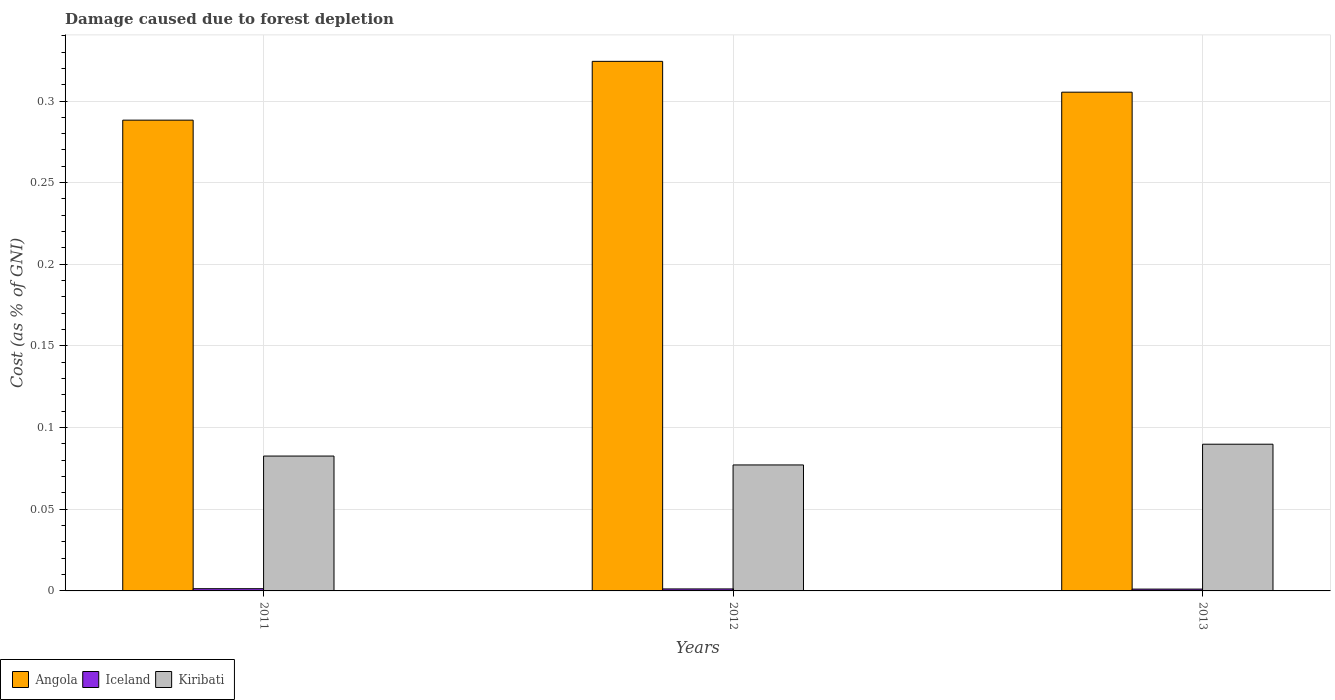How many different coloured bars are there?
Ensure brevity in your answer.  3. Are the number of bars on each tick of the X-axis equal?
Your answer should be very brief. Yes. How many bars are there on the 2nd tick from the right?
Make the answer very short. 3. What is the label of the 1st group of bars from the left?
Keep it short and to the point. 2011. What is the cost of damage caused due to forest depletion in Kiribati in 2013?
Provide a succinct answer. 0.09. Across all years, what is the maximum cost of damage caused due to forest depletion in Kiribati?
Offer a terse response. 0.09. Across all years, what is the minimum cost of damage caused due to forest depletion in Kiribati?
Your response must be concise. 0.08. In which year was the cost of damage caused due to forest depletion in Iceland minimum?
Offer a very short reply. 2013. What is the total cost of damage caused due to forest depletion in Iceland in the graph?
Your response must be concise. 0. What is the difference between the cost of damage caused due to forest depletion in Kiribati in 2012 and that in 2013?
Provide a short and direct response. -0.01. What is the difference between the cost of damage caused due to forest depletion in Iceland in 2012 and the cost of damage caused due to forest depletion in Kiribati in 2013?
Your answer should be very brief. -0.09. What is the average cost of damage caused due to forest depletion in Iceland per year?
Offer a terse response. 0. In the year 2013, what is the difference between the cost of damage caused due to forest depletion in Iceland and cost of damage caused due to forest depletion in Angola?
Your answer should be very brief. -0.3. What is the ratio of the cost of damage caused due to forest depletion in Angola in 2012 to that in 2013?
Keep it short and to the point. 1.06. Is the cost of damage caused due to forest depletion in Iceland in 2011 less than that in 2013?
Provide a succinct answer. No. Is the difference between the cost of damage caused due to forest depletion in Iceland in 2011 and 2012 greater than the difference between the cost of damage caused due to forest depletion in Angola in 2011 and 2012?
Make the answer very short. Yes. What is the difference between the highest and the second highest cost of damage caused due to forest depletion in Angola?
Ensure brevity in your answer.  0.02. What is the difference between the highest and the lowest cost of damage caused due to forest depletion in Angola?
Make the answer very short. 0.04. What does the 1st bar from the left in 2013 represents?
Ensure brevity in your answer.  Angola. What does the 3rd bar from the right in 2011 represents?
Keep it short and to the point. Angola. Are all the bars in the graph horizontal?
Provide a short and direct response. No. How many years are there in the graph?
Offer a terse response. 3. What is the difference between two consecutive major ticks on the Y-axis?
Make the answer very short. 0.05. Does the graph contain grids?
Offer a terse response. Yes. Where does the legend appear in the graph?
Offer a very short reply. Bottom left. How are the legend labels stacked?
Keep it short and to the point. Horizontal. What is the title of the graph?
Ensure brevity in your answer.  Damage caused due to forest depletion. Does "Uruguay" appear as one of the legend labels in the graph?
Offer a very short reply. No. What is the label or title of the Y-axis?
Offer a very short reply. Cost (as % of GNI). What is the Cost (as % of GNI) in Angola in 2011?
Your answer should be compact. 0.29. What is the Cost (as % of GNI) of Iceland in 2011?
Offer a very short reply. 0. What is the Cost (as % of GNI) in Kiribati in 2011?
Provide a succinct answer. 0.08. What is the Cost (as % of GNI) in Angola in 2012?
Provide a short and direct response. 0.32. What is the Cost (as % of GNI) in Iceland in 2012?
Keep it short and to the point. 0. What is the Cost (as % of GNI) of Kiribati in 2012?
Ensure brevity in your answer.  0.08. What is the Cost (as % of GNI) of Angola in 2013?
Make the answer very short. 0.31. What is the Cost (as % of GNI) in Iceland in 2013?
Keep it short and to the point. 0. What is the Cost (as % of GNI) in Kiribati in 2013?
Offer a very short reply. 0.09. Across all years, what is the maximum Cost (as % of GNI) in Angola?
Ensure brevity in your answer.  0.32. Across all years, what is the maximum Cost (as % of GNI) in Iceland?
Make the answer very short. 0. Across all years, what is the maximum Cost (as % of GNI) in Kiribati?
Keep it short and to the point. 0.09. Across all years, what is the minimum Cost (as % of GNI) of Angola?
Your answer should be very brief. 0.29. Across all years, what is the minimum Cost (as % of GNI) in Iceland?
Provide a short and direct response. 0. Across all years, what is the minimum Cost (as % of GNI) in Kiribati?
Make the answer very short. 0.08. What is the total Cost (as % of GNI) of Angola in the graph?
Offer a terse response. 0.92. What is the total Cost (as % of GNI) in Iceland in the graph?
Keep it short and to the point. 0. What is the total Cost (as % of GNI) of Kiribati in the graph?
Ensure brevity in your answer.  0.25. What is the difference between the Cost (as % of GNI) of Angola in 2011 and that in 2012?
Make the answer very short. -0.04. What is the difference between the Cost (as % of GNI) in Kiribati in 2011 and that in 2012?
Keep it short and to the point. 0.01. What is the difference between the Cost (as % of GNI) of Angola in 2011 and that in 2013?
Your response must be concise. -0.02. What is the difference between the Cost (as % of GNI) in Kiribati in 2011 and that in 2013?
Offer a terse response. -0.01. What is the difference between the Cost (as % of GNI) of Angola in 2012 and that in 2013?
Provide a succinct answer. 0.02. What is the difference between the Cost (as % of GNI) of Kiribati in 2012 and that in 2013?
Make the answer very short. -0.01. What is the difference between the Cost (as % of GNI) in Angola in 2011 and the Cost (as % of GNI) in Iceland in 2012?
Provide a short and direct response. 0.29. What is the difference between the Cost (as % of GNI) of Angola in 2011 and the Cost (as % of GNI) of Kiribati in 2012?
Offer a very short reply. 0.21. What is the difference between the Cost (as % of GNI) of Iceland in 2011 and the Cost (as % of GNI) of Kiribati in 2012?
Provide a succinct answer. -0.08. What is the difference between the Cost (as % of GNI) of Angola in 2011 and the Cost (as % of GNI) of Iceland in 2013?
Your response must be concise. 0.29. What is the difference between the Cost (as % of GNI) of Angola in 2011 and the Cost (as % of GNI) of Kiribati in 2013?
Your answer should be very brief. 0.2. What is the difference between the Cost (as % of GNI) of Iceland in 2011 and the Cost (as % of GNI) of Kiribati in 2013?
Provide a short and direct response. -0.09. What is the difference between the Cost (as % of GNI) of Angola in 2012 and the Cost (as % of GNI) of Iceland in 2013?
Your answer should be compact. 0.32. What is the difference between the Cost (as % of GNI) in Angola in 2012 and the Cost (as % of GNI) in Kiribati in 2013?
Offer a very short reply. 0.23. What is the difference between the Cost (as % of GNI) in Iceland in 2012 and the Cost (as % of GNI) in Kiribati in 2013?
Make the answer very short. -0.09. What is the average Cost (as % of GNI) in Angola per year?
Offer a terse response. 0.31. What is the average Cost (as % of GNI) in Iceland per year?
Offer a terse response. 0. What is the average Cost (as % of GNI) in Kiribati per year?
Keep it short and to the point. 0.08. In the year 2011, what is the difference between the Cost (as % of GNI) of Angola and Cost (as % of GNI) of Iceland?
Offer a very short reply. 0.29. In the year 2011, what is the difference between the Cost (as % of GNI) in Angola and Cost (as % of GNI) in Kiribati?
Make the answer very short. 0.21. In the year 2011, what is the difference between the Cost (as % of GNI) in Iceland and Cost (as % of GNI) in Kiribati?
Offer a terse response. -0.08. In the year 2012, what is the difference between the Cost (as % of GNI) in Angola and Cost (as % of GNI) in Iceland?
Make the answer very short. 0.32. In the year 2012, what is the difference between the Cost (as % of GNI) of Angola and Cost (as % of GNI) of Kiribati?
Your answer should be very brief. 0.25. In the year 2012, what is the difference between the Cost (as % of GNI) of Iceland and Cost (as % of GNI) of Kiribati?
Your answer should be compact. -0.08. In the year 2013, what is the difference between the Cost (as % of GNI) in Angola and Cost (as % of GNI) in Iceland?
Provide a succinct answer. 0.3. In the year 2013, what is the difference between the Cost (as % of GNI) in Angola and Cost (as % of GNI) in Kiribati?
Ensure brevity in your answer.  0.22. In the year 2013, what is the difference between the Cost (as % of GNI) of Iceland and Cost (as % of GNI) of Kiribati?
Your response must be concise. -0.09. What is the ratio of the Cost (as % of GNI) of Angola in 2011 to that in 2012?
Your answer should be very brief. 0.89. What is the ratio of the Cost (as % of GNI) in Iceland in 2011 to that in 2012?
Make the answer very short. 1.11. What is the ratio of the Cost (as % of GNI) in Kiribati in 2011 to that in 2012?
Offer a terse response. 1.07. What is the ratio of the Cost (as % of GNI) in Angola in 2011 to that in 2013?
Ensure brevity in your answer.  0.94. What is the ratio of the Cost (as % of GNI) in Iceland in 2011 to that in 2013?
Offer a terse response. 1.22. What is the ratio of the Cost (as % of GNI) of Kiribati in 2011 to that in 2013?
Offer a terse response. 0.92. What is the ratio of the Cost (as % of GNI) of Angola in 2012 to that in 2013?
Your answer should be very brief. 1.06. What is the ratio of the Cost (as % of GNI) in Iceland in 2012 to that in 2013?
Offer a very short reply. 1.1. What is the ratio of the Cost (as % of GNI) in Kiribati in 2012 to that in 2013?
Ensure brevity in your answer.  0.86. What is the difference between the highest and the second highest Cost (as % of GNI) of Angola?
Offer a very short reply. 0.02. What is the difference between the highest and the second highest Cost (as % of GNI) of Iceland?
Your response must be concise. 0. What is the difference between the highest and the second highest Cost (as % of GNI) in Kiribati?
Your answer should be compact. 0.01. What is the difference between the highest and the lowest Cost (as % of GNI) in Angola?
Give a very brief answer. 0.04. What is the difference between the highest and the lowest Cost (as % of GNI) in Kiribati?
Your answer should be compact. 0.01. 